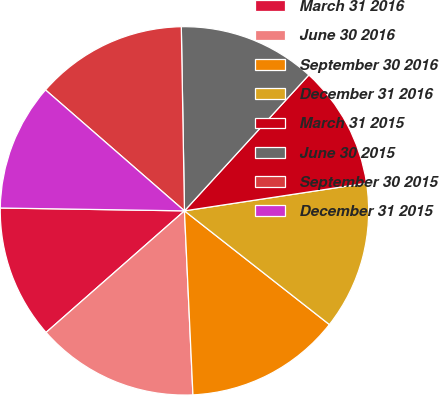Convert chart to OTSL. <chart><loc_0><loc_0><loc_500><loc_500><pie_chart><fcel>March 31 2016<fcel>June 30 2016<fcel>September 30 2016<fcel>December 31 2016<fcel>March 31 2015<fcel>June 30 2015<fcel>September 30 2015<fcel>December 31 2015<nl><fcel>11.72%<fcel>14.26%<fcel>13.68%<fcel>12.99%<fcel>10.8%<fcel>12.07%<fcel>13.33%<fcel>11.15%<nl></chart> 